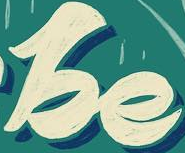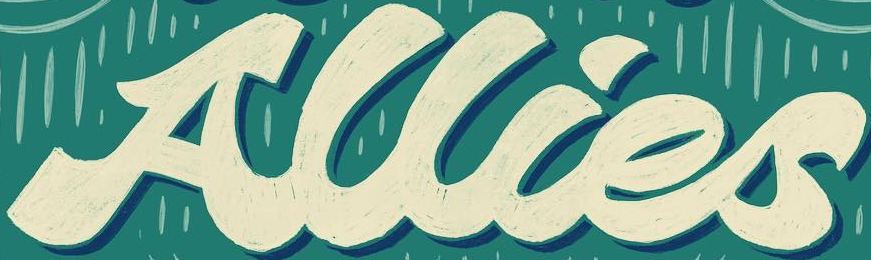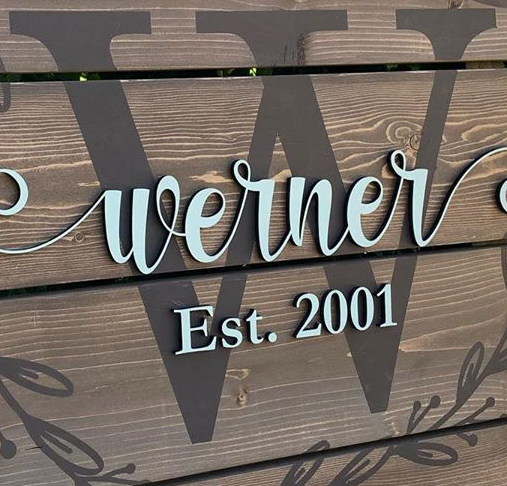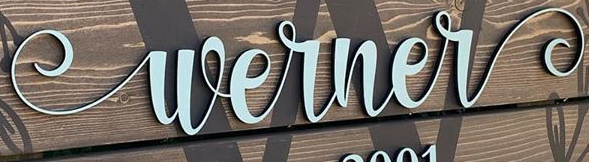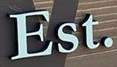Identify the words shown in these images in order, separated by a semicolon. be; Allies; W; Werner; Est. 